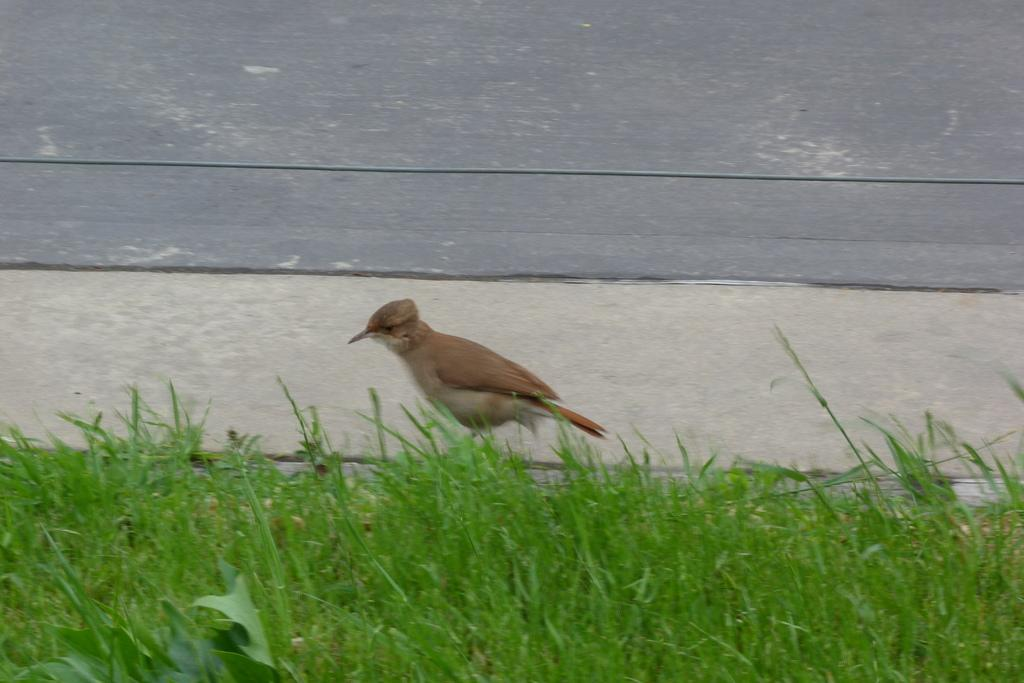What type of animal can be seen on the ground in the image? There is a bird on the ground in the image. What type of terrain is visible in the foreground of the image? There is grassland in the foreground of the image. What type of structure can be seen in the background of the image? There is a wall in the background of the image. What type of battle is taking place in the image? There is no battle present in the image; it features a bird on the ground, grassland in the foreground, and a wall in the background. How many snakes can be seen slithering through the grass in the image? There are no snakes present in the image; it features a bird on the ground, grassland in the foreground, and a wall in the background. 